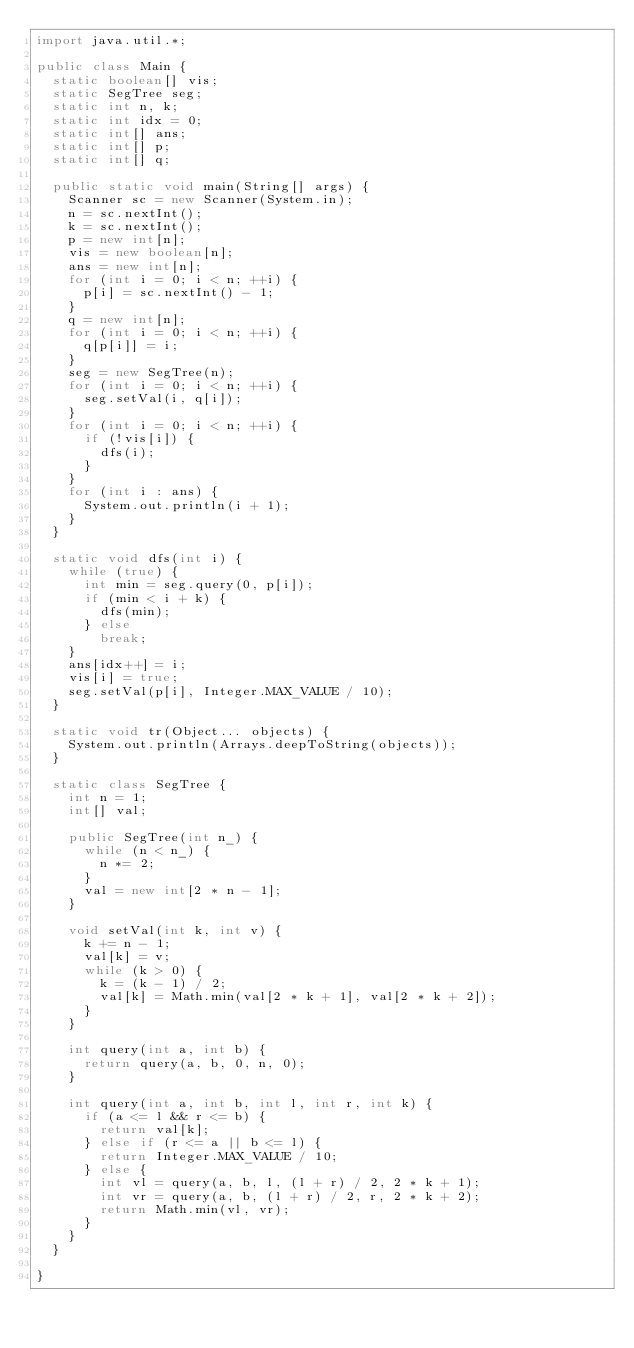Convert code to text. <code><loc_0><loc_0><loc_500><loc_500><_Java_>import java.util.*;

public class Main {
	static boolean[] vis;
	static SegTree seg;
	static int n, k;
	static int idx = 0;
	static int[] ans;
	static int[] p;
	static int[] q;

	public static void main(String[] args) {
		Scanner sc = new Scanner(System.in);
		n = sc.nextInt();
		k = sc.nextInt();
		p = new int[n];
		vis = new boolean[n];
		ans = new int[n];
		for (int i = 0; i < n; ++i) {
			p[i] = sc.nextInt() - 1;
		}
		q = new int[n];
		for (int i = 0; i < n; ++i) {
			q[p[i]] = i;
		}
		seg = new SegTree(n);
		for (int i = 0; i < n; ++i) {
			seg.setVal(i, q[i]);
		}
		for (int i = 0; i < n; ++i) {
			if (!vis[i]) {
				dfs(i);
			}
		}
		for (int i : ans) {
			System.out.println(i + 1);
		}
	}

	static void dfs(int i) {
		while (true) {
			int min = seg.query(0, p[i]);
			if (min < i + k) {
				dfs(min);
			} else
				break;
		}
		ans[idx++] = i;
		vis[i] = true;
		seg.setVal(p[i], Integer.MAX_VALUE / 10);
	}

	static void tr(Object... objects) {
		System.out.println(Arrays.deepToString(objects));
	}

	static class SegTree {
		int n = 1;
		int[] val;

		public SegTree(int n_) {
			while (n < n_) {
				n *= 2;
			}
			val = new int[2 * n - 1];
		}

		void setVal(int k, int v) {
			k += n - 1;
			val[k] = v;
			while (k > 0) {
				k = (k - 1) / 2;
				val[k] = Math.min(val[2 * k + 1], val[2 * k + 2]);
			}
		}

		int query(int a, int b) {
			return query(a, b, 0, n, 0);
		}

		int query(int a, int b, int l, int r, int k) {
			if (a <= l && r <= b) {
				return val[k];
			} else if (r <= a || b <= l) {
				return Integer.MAX_VALUE / 10;
			} else {
				int vl = query(a, b, l, (l + r) / 2, 2 * k + 1);
				int vr = query(a, b, (l + r) / 2, r, 2 * k + 2);
				return Math.min(vl, vr);
			}
		}
	}

}
</code> 